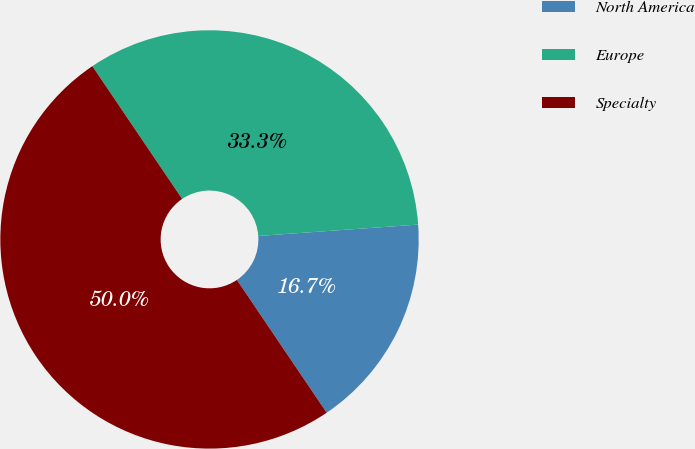Convert chart to OTSL. <chart><loc_0><loc_0><loc_500><loc_500><pie_chart><fcel>North America<fcel>Europe<fcel>Specialty<nl><fcel>16.67%<fcel>33.33%<fcel>50.0%<nl></chart> 